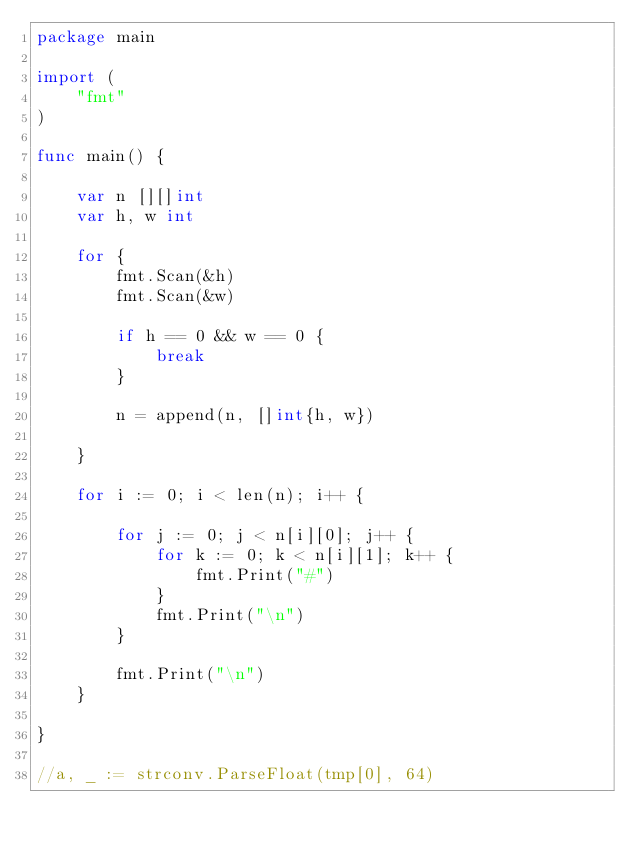Convert code to text. <code><loc_0><loc_0><loc_500><loc_500><_Go_>package main

import (
	"fmt"
)

func main() {

	var n [][]int
	var h, w int

	for {
		fmt.Scan(&h)
		fmt.Scan(&w)

		if h == 0 && w == 0 {
			break
		}

		n = append(n, []int{h, w})

	}

	for i := 0; i < len(n); i++ {

		for j := 0; j < n[i][0]; j++ {
			for k := 0; k < n[i][1]; k++ {
				fmt.Print("#")
			}
			fmt.Print("\n")
		}

		fmt.Print("\n")
	}

}

//a, _ := strconv.ParseFloat(tmp[0], 64)

</code> 